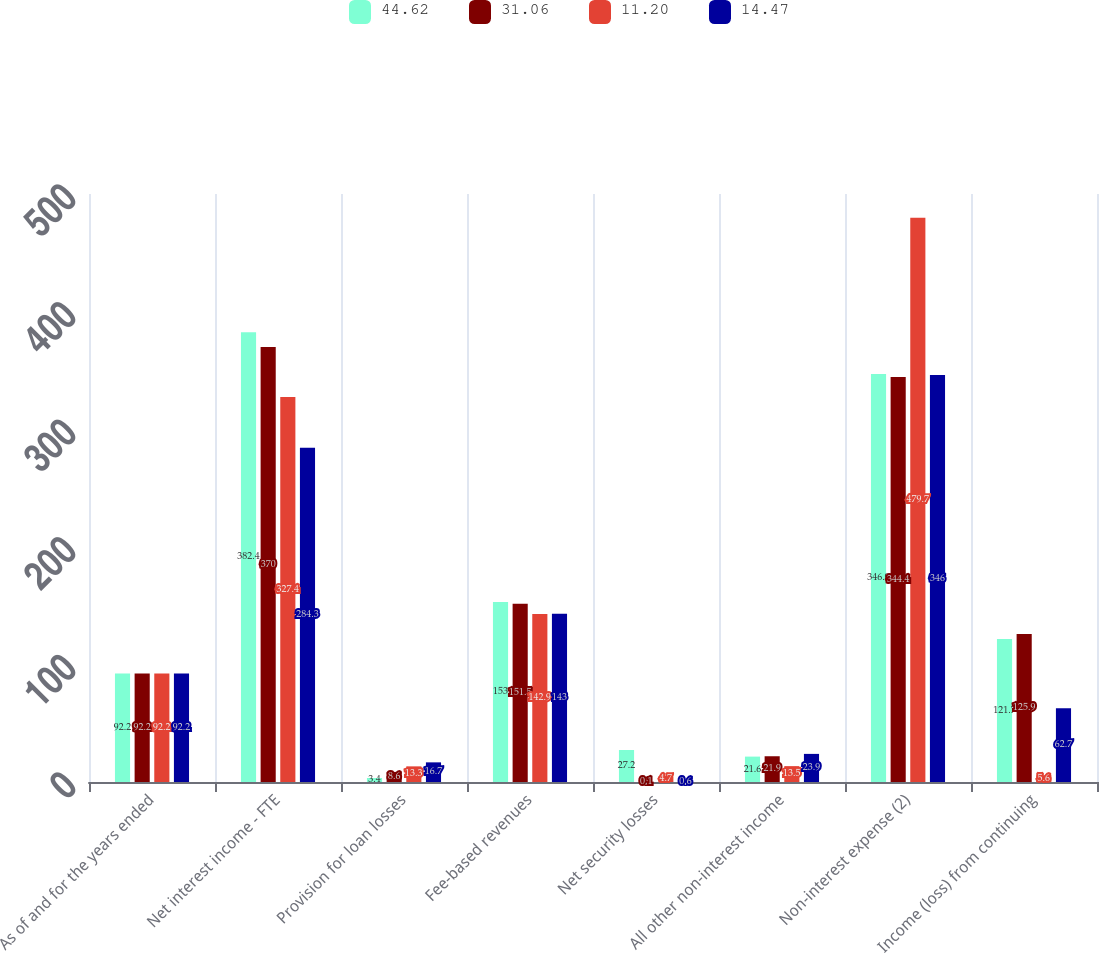<chart> <loc_0><loc_0><loc_500><loc_500><stacked_bar_chart><ecel><fcel>As of and for the years ended<fcel>Net interest income - FTE<fcel>Provision for loan losses<fcel>Fee-based revenues<fcel>Net security losses<fcel>All other non-interest income<fcel>Non-interest expense (2)<fcel>Income (loss) from continuing<nl><fcel>44.62<fcel>92.2<fcel>382.4<fcel>3.4<fcel>153<fcel>27.2<fcel>21.6<fcel>346.9<fcel>121.7<nl><fcel>31.06<fcel>92.2<fcel>370<fcel>8.6<fcel>151.5<fcel>0.1<fcel>21.9<fcel>344.4<fcel>125.9<nl><fcel>11.2<fcel>92.2<fcel>327.4<fcel>13.3<fcel>142.9<fcel>4.7<fcel>13.5<fcel>479.7<fcel>5.6<nl><fcel>14.47<fcel>92.2<fcel>284.3<fcel>16.7<fcel>143<fcel>0.6<fcel>23.9<fcel>346<fcel>62.7<nl></chart> 